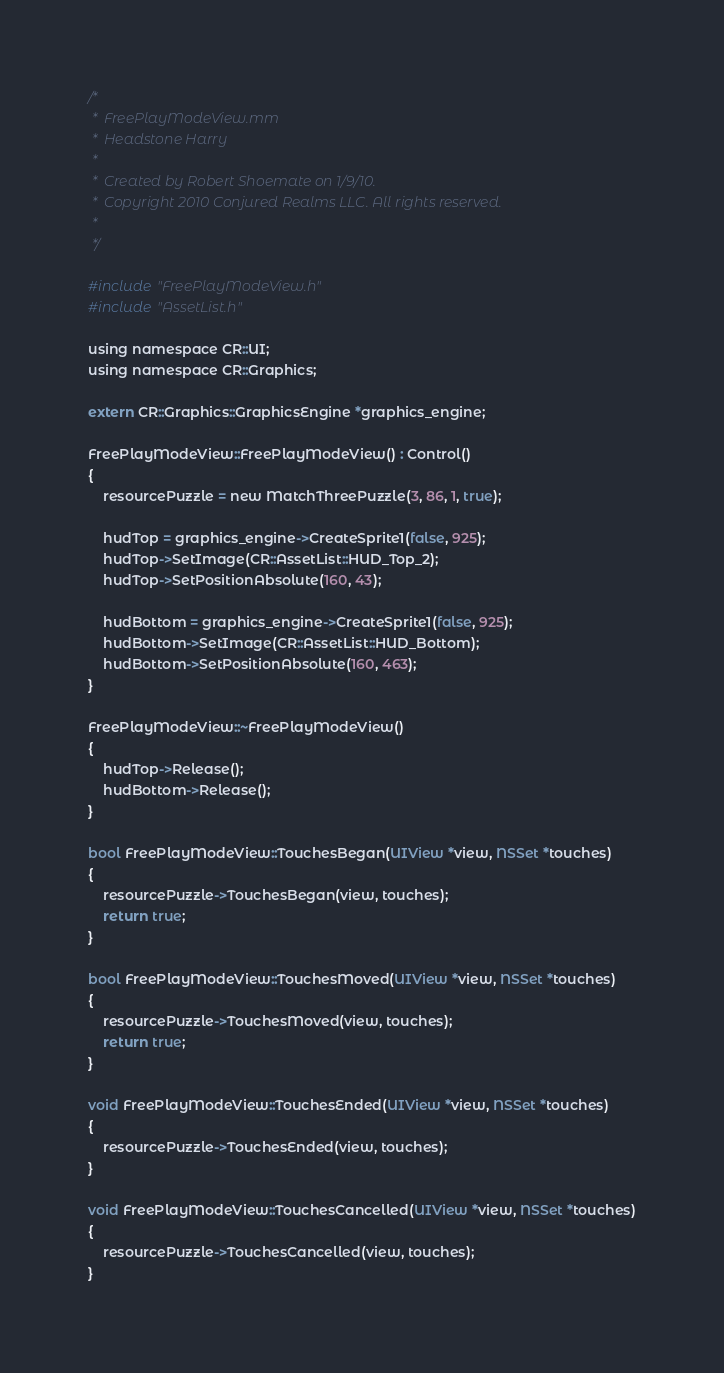<code> <loc_0><loc_0><loc_500><loc_500><_ObjectiveC_>/*
 *  FreePlayModeView.mm
 *  Headstone Harry
 *
 *  Created by Robert Shoemate on 1/9/10.
 *  Copyright 2010 Conjured Realms LLC. All rights reserved.
 *
 */

#include "FreePlayModeView.h"
#include "AssetList.h"

using namespace CR::UI;
using namespace CR::Graphics;

extern CR::Graphics::GraphicsEngine *graphics_engine;

FreePlayModeView::FreePlayModeView() : Control()
{
	resourcePuzzle = new MatchThreePuzzle(3, 86, 1, true);
	
	hudTop = graphics_engine->CreateSprite1(false, 925);
	hudTop->SetImage(CR::AssetList::HUD_Top_2);
	hudTop->SetPositionAbsolute(160, 43);
	
	hudBottom = graphics_engine->CreateSprite1(false, 925);
	hudBottom->SetImage(CR::AssetList::HUD_Bottom);
	hudBottom->SetPositionAbsolute(160, 463);
}

FreePlayModeView::~FreePlayModeView()
{
	hudTop->Release();
	hudBottom->Release();
}

bool FreePlayModeView::TouchesBegan(UIView *view, NSSet *touches)
{
	resourcePuzzle->TouchesBegan(view, touches);
	return true;
}

bool FreePlayModeView::TouchesMoved(UIView *view, NSSet *touches)
{
	resourcePuzzle->TouchesMoved(view, touches);
	return true;
}

void FreePlayModeView::TouchesEnded(UIView *view, NSSet *touches)
{
	resourcePuzzle->TouchesEnded(view, touches);
}

void FreePlayModeView::TouchesCancelled(UIView *view, NSSet *touches)
{
	resourcePuzzle->TouchesCancelled(view, touches);
}
</code> 